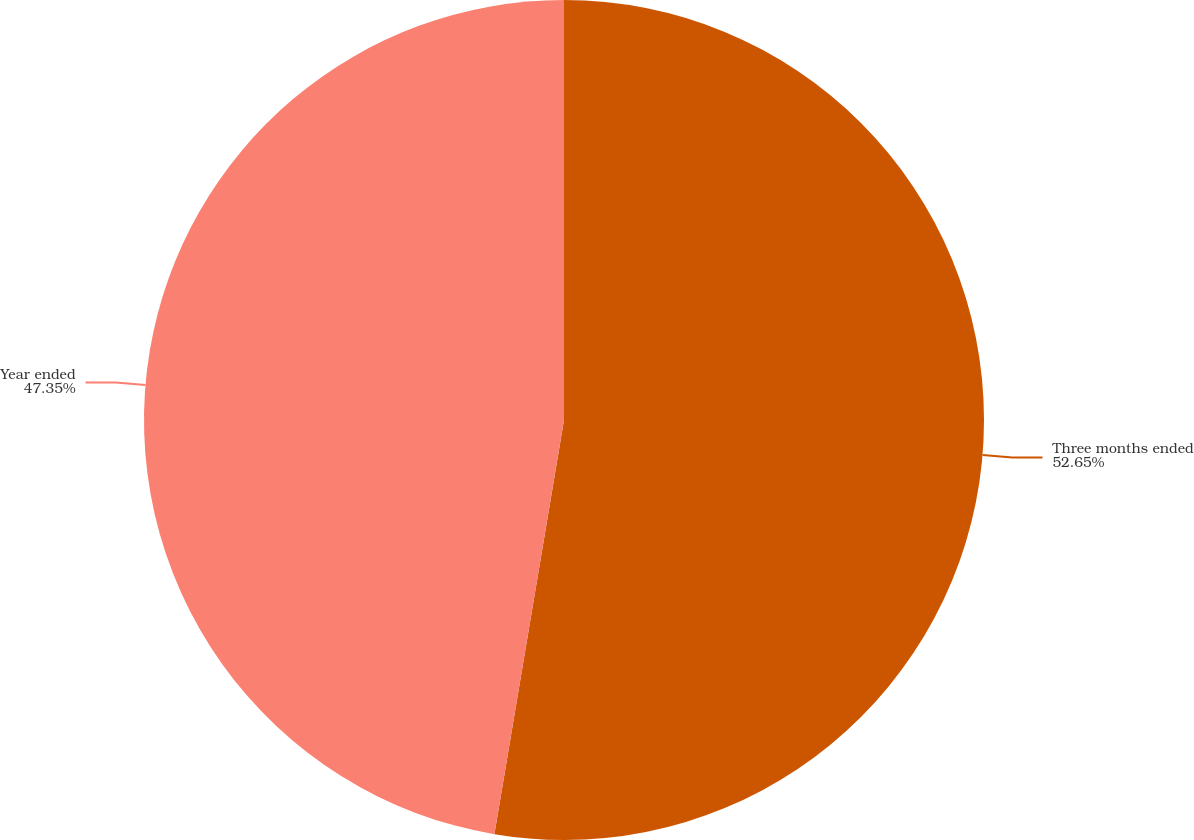<chart> <loc_0><loc_0><loc_500><loc_500><pie_chart><fcel>Three months ended<fcel>Year ended<nl><fcel>52.65%<fcel>47.35%<nl></chart> 